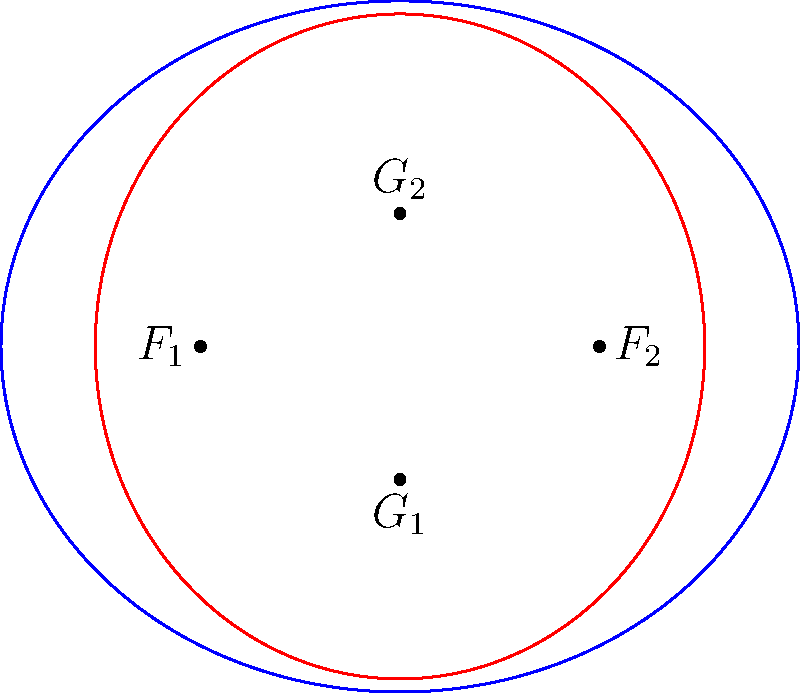Consider two ellipses in the plane: ellipse $E_1$ with foci at $F_1(-1.5,0)$ and $F_2(1.5,0)$, and ellipse $E_2$ with foci at $G_1(0,-1)$ and $G_2(0,1)$. The semi-major axis of $E_1$ is 1.5 units, and the semi-major axis of $E_2$ is 1.25 units. Determine the maximum number of intersection points between these two ellipses. To solve this problem, we'll follow these steps:

1) First, recall that the maximum number of intersection points between two distinct ellipses is 4. This is because ellipses are second-degree curves, and by Bézout's theorem, two curves of degrees $m$ and $n$ intersect in at most $mn$ points.

2) However, we need to check if these ellipses are in a special configuration that might reduce the number of intersections.

3) Calculate the eccentricities of the ellipses:
   For $E_1$: $e_1 = \frac{c_1}{a_1} = \frac{1.5}{1.5} = 1$
   For $E_2$: $e_2 = \frac{c_2}{a_2} = \frac{1}{1.25} = 0.8$

4) Since the eccentricities are different, the ellipses are not similar and do not share a center.

5) The ellipses have perpendicular major axes, which means they are not in any special alignment that would reduce the number of intersections.

6) Given that the ellipses have different shapes, sizes, and orientations, and are not in any special configuration, we can conclude that they will intersect in the maximum number of points possible for two ellipses.

Therefore, the maximum number of intersection points between these two ellipses is 4.
Answer: 4 